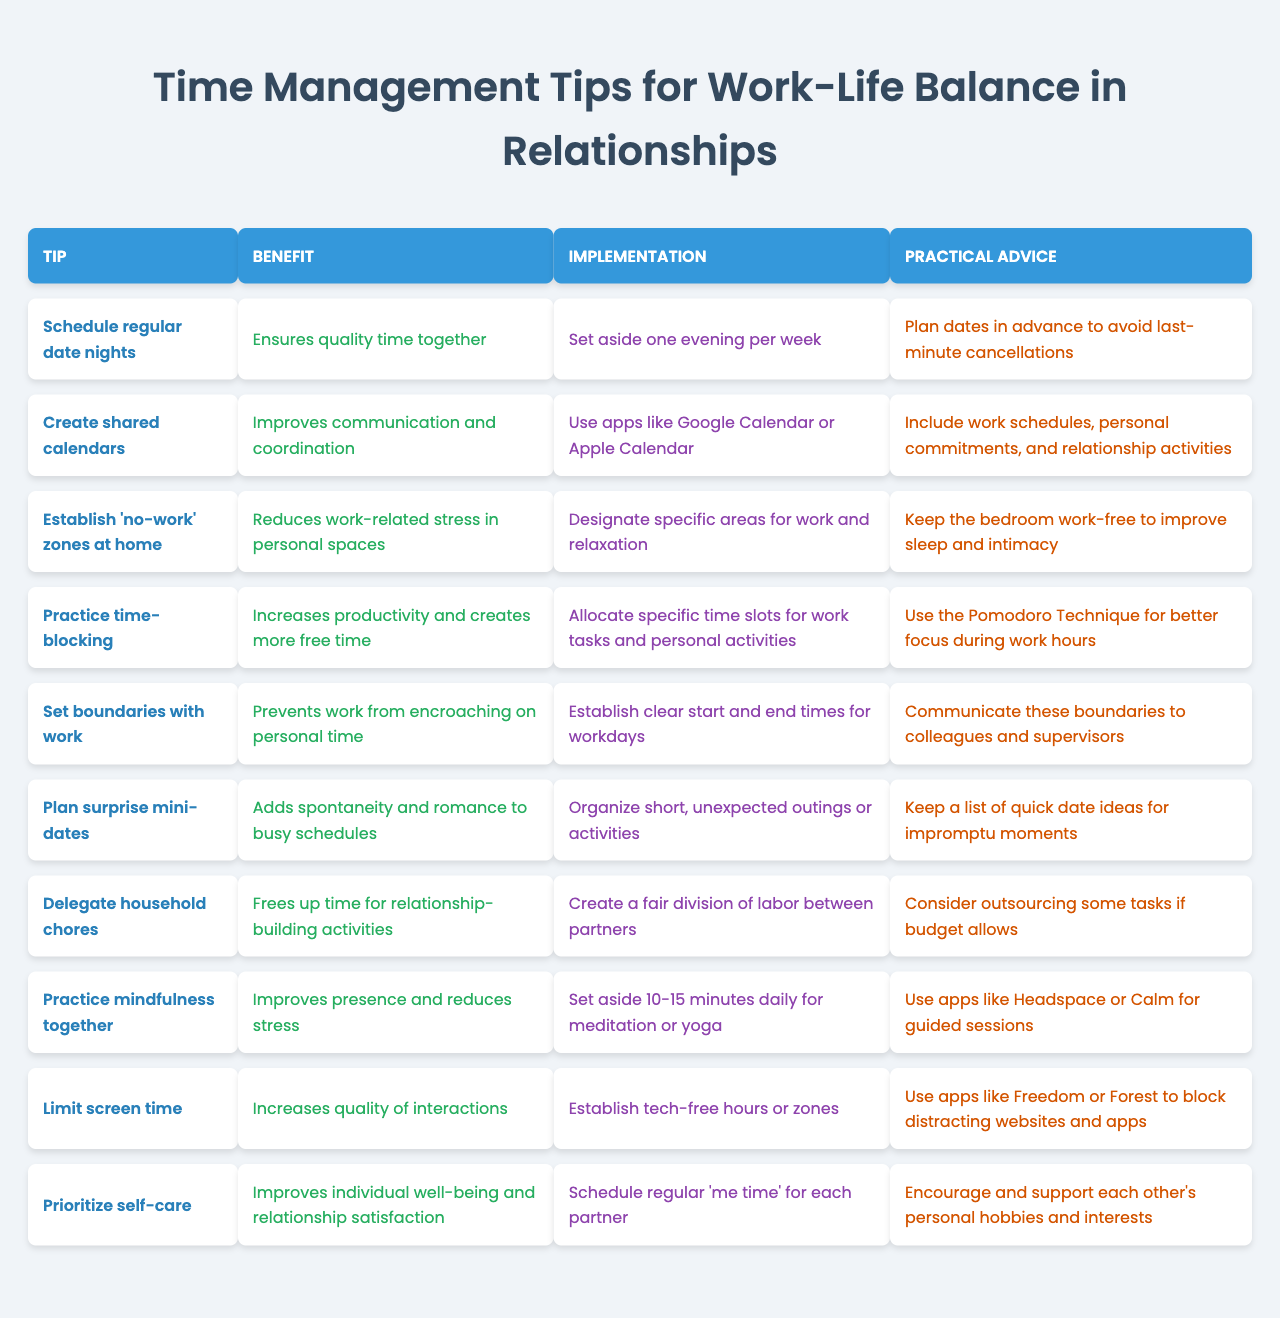What is the benefit of scheduling regular date nights? The benefit of scheduling regular date nights is that it ensures quality time together.
Answer: Ensures quality time together How can establishing 'no-work' zones at home help in reducing stress? Establishing 'no-work' zones at home helps in reducing work-related stress in personal spaces by designating areas specifically for relaxation.
Answer: Reduces work-related stress in personal spaces What is one practical piece of advice for creating shared calendars? One practical piece of advice for creating shared calendars is to include work schedules, personal commitments, and relationship activities.
Answer: Include work schedules, personal commitments, and relationship activities What do you gain from practicing mindfulness together? Practicing mindfulness together improves presence and reduces stress.
Answer: Improves presence and reduces stress Can limiting screen time increase the quality of interactions? Yes, limiting screen time can increase the quality of interactions through establishing tech-free hours or zones.
Answer: Yes Is the benefit of delegating household chores to free up time for relationship-building activities? Yes, the benefit of delegating household chores is to free up time for relationship-building activities.
Answer: Yes What is the implementation step associated with practicing time-blocking? The implementation step associated with practicing time-blocking is to allocate specific time slots for work tasks and personal activities.
Answer: Allocate specific time slots for work tasks and personal activities If a couple practices the Pomodoro Technique while time-blocking, how does this affect productivity? The Pomodoro Technique enhances productivity by allowing better focus during work hours, thereby creating more free time.
Answer: It increases productivity What is the common thread among the benefits of these time management tips? The common thread among the benefits is that they all aim to improve the balance between work and personal life, fostering stronger relationships.
Answer: Improve the balance between work and personal life How many tips focus on establishing routines for quality time? There are three tips that focus on establishing routines for quality time: scheduling regular date nights, planning surprise mini-dates, and practicing mindfulness together.
Answer: Three tips 